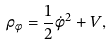Convert formula to latex. <formula><loc_0><loc_0><loc_500><loc_500>\rho _ { \phi } = \frac { 1 } { 2 } \dot { \phi } ^ { 2 } + V ,</formula> 